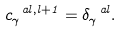<formula> <loc_0><loc_0><loc_500><loc_500>c ^ { \ a l , l + 1 } _ { \gamma } = \delta ^ { \ a l } _ { \gamma } .</formula> 